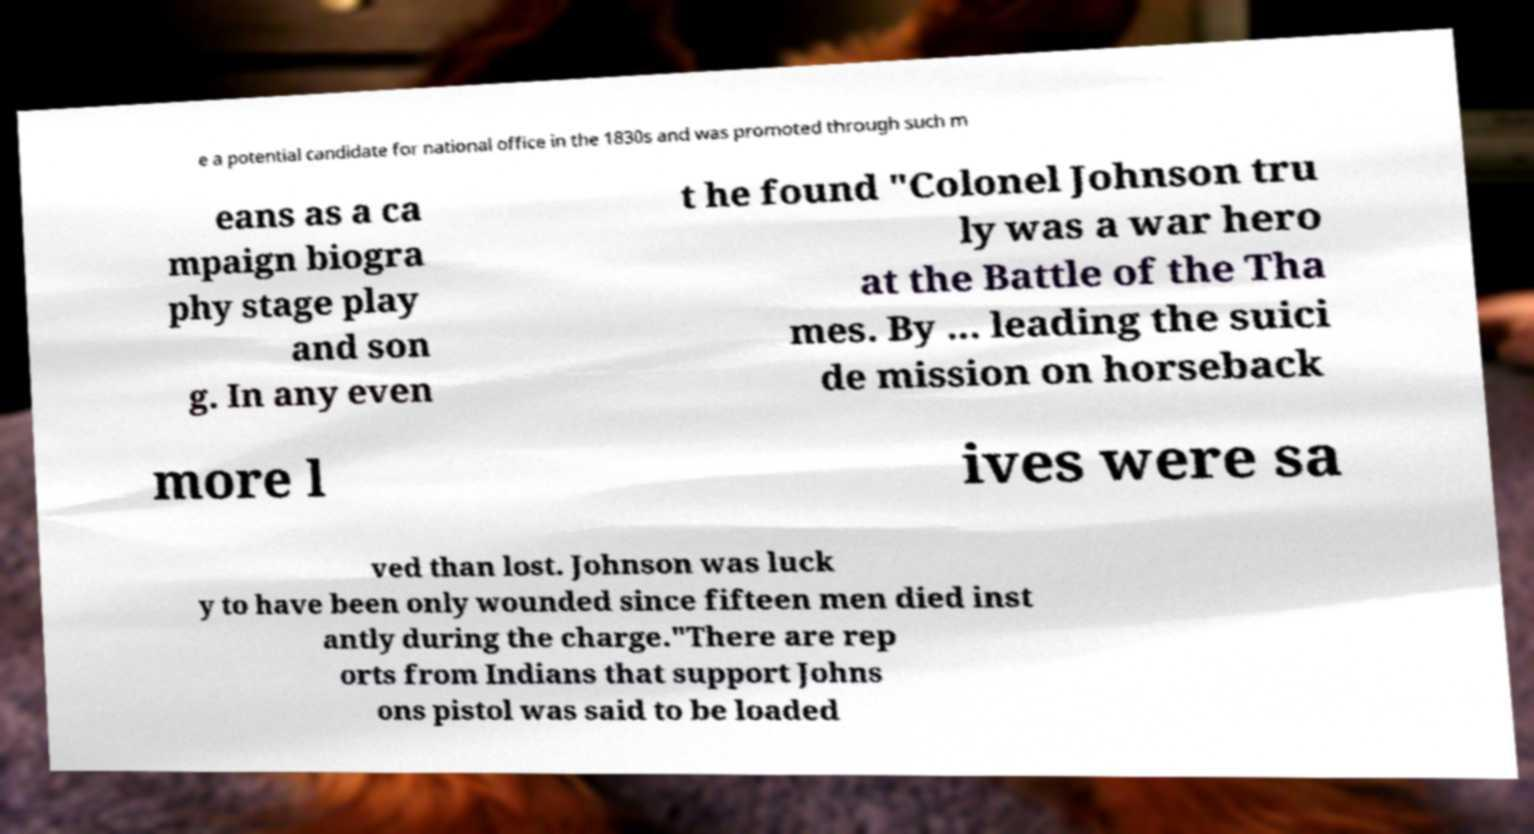I need the written content from this picture converted into text. Can you do that? e a potential candidate for national office in the 1830s and was promoted through such m eans as a ca mpaign biogra phy stage play and son g. In any even t he found "Colonel Johnson tru ly was a war hero at the Battle of the Tha mes. By ... leading the suici de mission on horseback more l ives were sa ved than lost. Johnson was luck y to have been only wounded since fifteen men died inst antly during the charge."There are rep orts from Indians that support Johns ons pistol was said to be loaded 